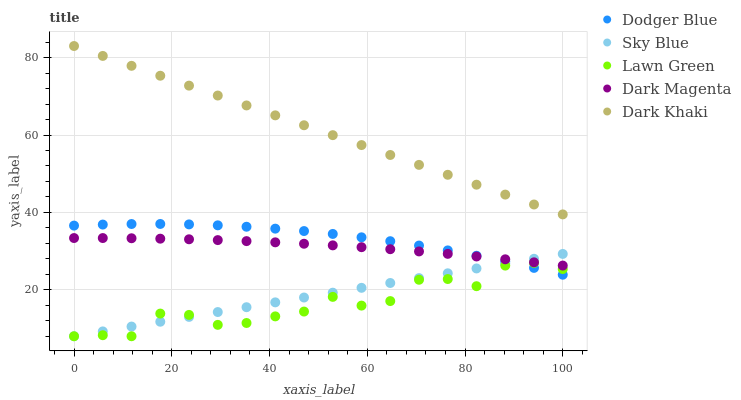Does Lawn Green have the minimum area under the curve?
Answer yes or no. Yes. Does Dark Khaki have the maximum area under the curve?
Answer yes or no. Yes. Does Sky Blue have the minimum area under the curve?
Answer yes or no. No. Does Sky Blue have the maximum area under the curve?
Answer yes or no. No. Is Sky Blue the smoothest?
Answer yes or no. Yes. Is Lawn Green the roughest?
Answer yes or no. Yes. Is Dodger Blue the smoothest?
Answer yes or no. No. Is Dodger Blue the roughest?
Answer yes or no. No. Does Sky Blue have the lowest value?
Answer yes or no. Yes. Does Dodger Blue have the lowest value?
Answer yes or no. No. Does Dark Khaki have the highest value?
Answer yes or no. Yes. Does Sky Blue have the highest value?
Answer yes or no. No. Is Lawn Green less than Dark Khaki?
Answer yes or no. Yes. Is Dark Khaki greater than Dark Magenta?
Answer yes or no. Yes. Does Sky Blue intersect Dark Magenta?
Answer yes or no. Yes. Is Sky Blue less than Dark Magenta?
Answer yes or no. No. Is Sky Blue greater than Dark Magenta?
Answer yes or no. No. Does Lawn Green intersect Dark Khaki?
Answer yes or no. No. 